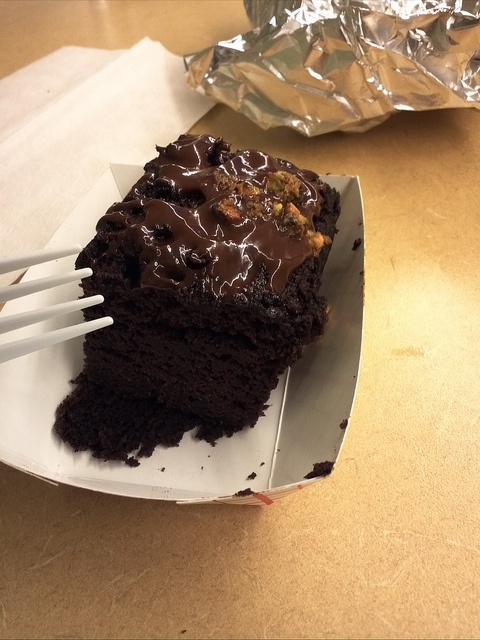Describe the objects in this image and their specific colors. I can see cake in tan, black, maroon, and gray tones and fork in tan, darkgray, and lightgray tones in this image. 